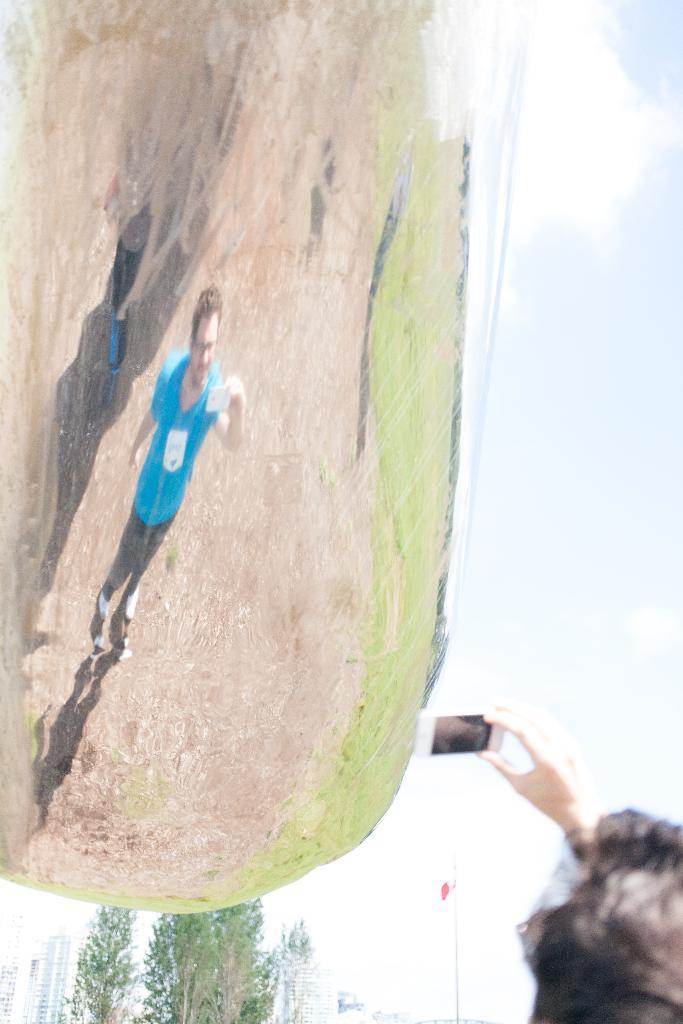What is the main subject of the image? There is a person in the image. What is the person holding in the image? The person is holding a mobile in the image. What else can be seen in the image besides the person and the mobile? There is a picture, trees, buildings, and the sky visible in the image. How does the person twist the channel while holding the mobile in the image? There is no indication in the image that the person is twisting a channel or that there is a channel to twist. 